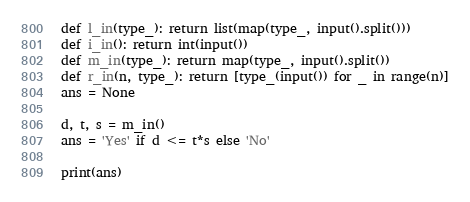<code> <loc_0><loc_0><loc_500><loc_500><_Python_>def l_in(type_): return list(map(type_, input().split()))
def i_in(): return int(input())
def m_in(type_): return map(type_, input().split())
def r_in(n, type_): return [type_(input()) for _ in range(n)]
ans = None

d, t, s = m_in()
ans = 'Yes' if d <= t*s else 'No'

print(ans)
</code> 